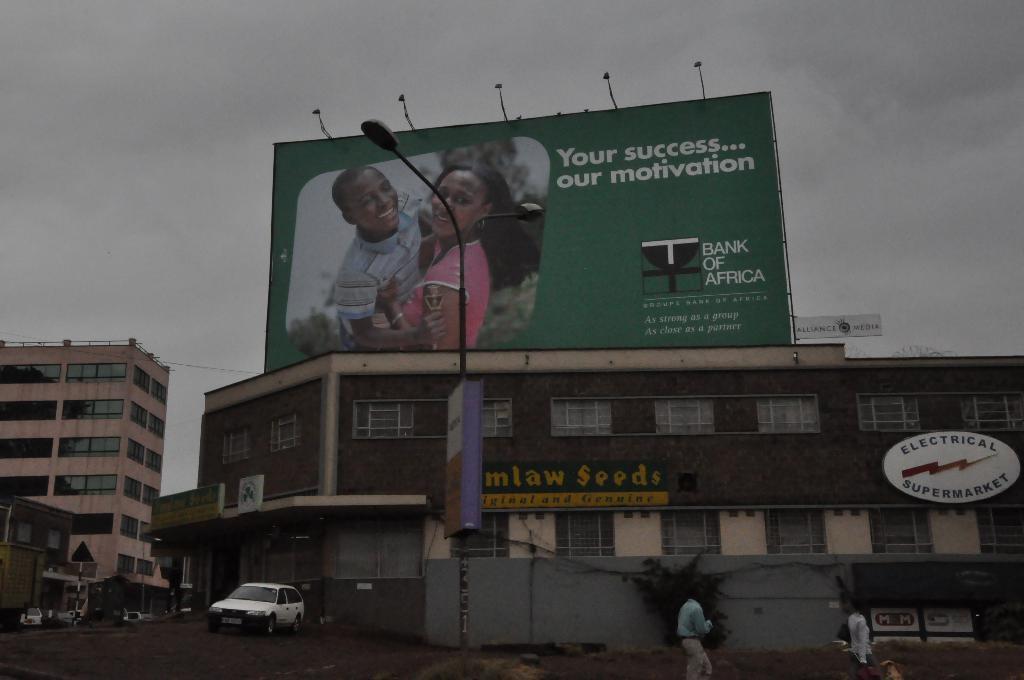Can you describe this image briefly? In this image we can see a few buildings, on the building we can see a board with some images and text, there are some trees, windows, people, vehicles, boards, poles and lights, in the background we can see the sky. 